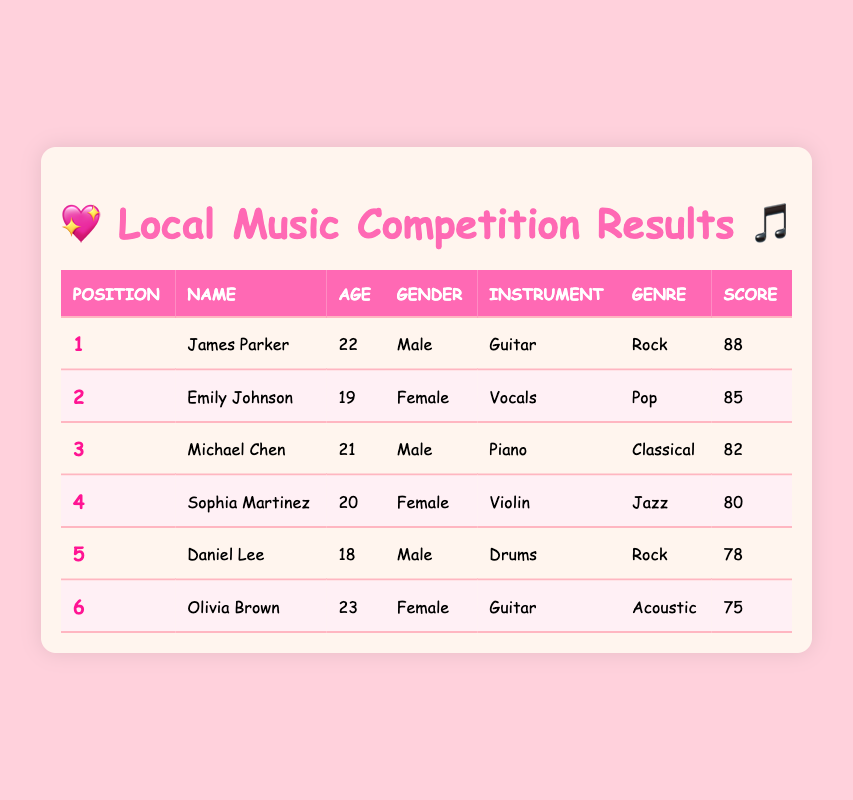What is the name of the participant who scored the highest? The highest score in the table is 88, which belongs to James Parker.
Answer: James Parker How many female participants are there in the competition? There are three female participants listed in the table: Emily Johnson, Sophia Martinez, and Olivia Brown.
Answer: 3 What is the average score of all participants? The scores of all participants are 88, 85, 82, 80, 78, and 75. The total score is 88 + 85 + 82 + 80 + 78 + 75 = 488. There are 6 participants, so the average score is 488 / 6 = 81.33.
Answer: 81.33 Is there a male participant who plays the violin? No, there is no male participant listed who plays the violin. Sophia Martinez, the only violin player, is female.
Answer: No Who is the oldest participant, and how old are they? Olivia Brown is the oldest participant at 23 years old.
Answer: Olivia Brown, 23 What is the difference between the highest and lowest scores? The highest score is 88 from James Parker, and the lowest score is 75 from Olivia Brown. The difference is 88 - 75 = 13.
Answer: 13 Does any participant play an instrument in two different genres? No, each participant plays a distinct instrument within a single genre; there are no overlaps reported in the table.
Answer: No Which instrument is associated with the participant in the third position? The participant in the third position is Michael Chen, and he plays the piano.
Answer: Piano What percentage of participants are male? There are 6 participants total, and 3 of them are male: James Parker, Michael Chen, and Daniel Lee. The percentage of male participants is (3 / 6) * 100 = 50%.
Answer: 50% 